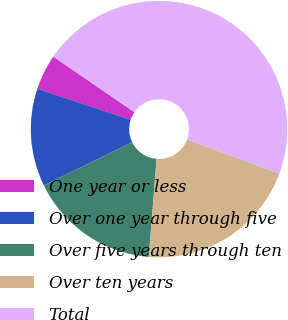<chart> <loc_0><loc_0><loc_500><loc_500><pie_chart><fcel>One year or less<fcel>Over one year through five<fcel>Over five years through ten<fcel>Over ten years<fcel>Total<nl><fcel>4.48%<fcel>12.33%<fcel>16.48%<fcel>20.64%<fcel>46.07%<nl></chart> 